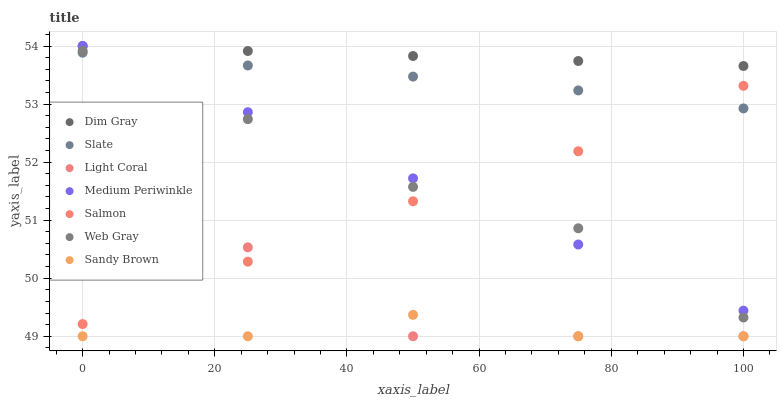Does Sandy Brown have the minimum area under the curve?
Answer yes or no. Yes. Does Dim Gray have the maximum area under the curve?
Answer yes or no. Yes. Does Medium Periwinkle have the minimum area under the curve?
Answer yes or no. No. Does Medium Periwinkle have the maximum area under the curve?
Answer yes or no. No. Is Dim Gray the smoothest?
Answer yes or no. Yes. Is Light Coral the roughest?
Answer yes or no. Yes. Is Medium Periwinkle the smoothest?
Answer yes or no. No. Is Medium Periwinkle the roughest?
Answer yes or no. No. Does Light Coral have the lowest value?
Answer yes or no. Yes. Does Medium Periwinkle have the lowest value?
Answer yes or no. No. Does Medium Periwinkle have the highest value?
Answer yes or no. Yes. Does Slate have the highest value?
Answer yes or no. No. Is Sandy Brown less than Web Gray?
Answer yes or no. Yes. Is Medium Periwinkle greater than Sandy Brown?
Answer yes or no. Yes. Does Slate intersect Salmon?
Answer yes or no. Yes. Is Slate less than Salmon?
Answer yes or no. No. Is Slate greater than Salmon?
Answer yes or no. No. Does Sandy Brown intersect Web Gray?
Answer yes or no. No. 